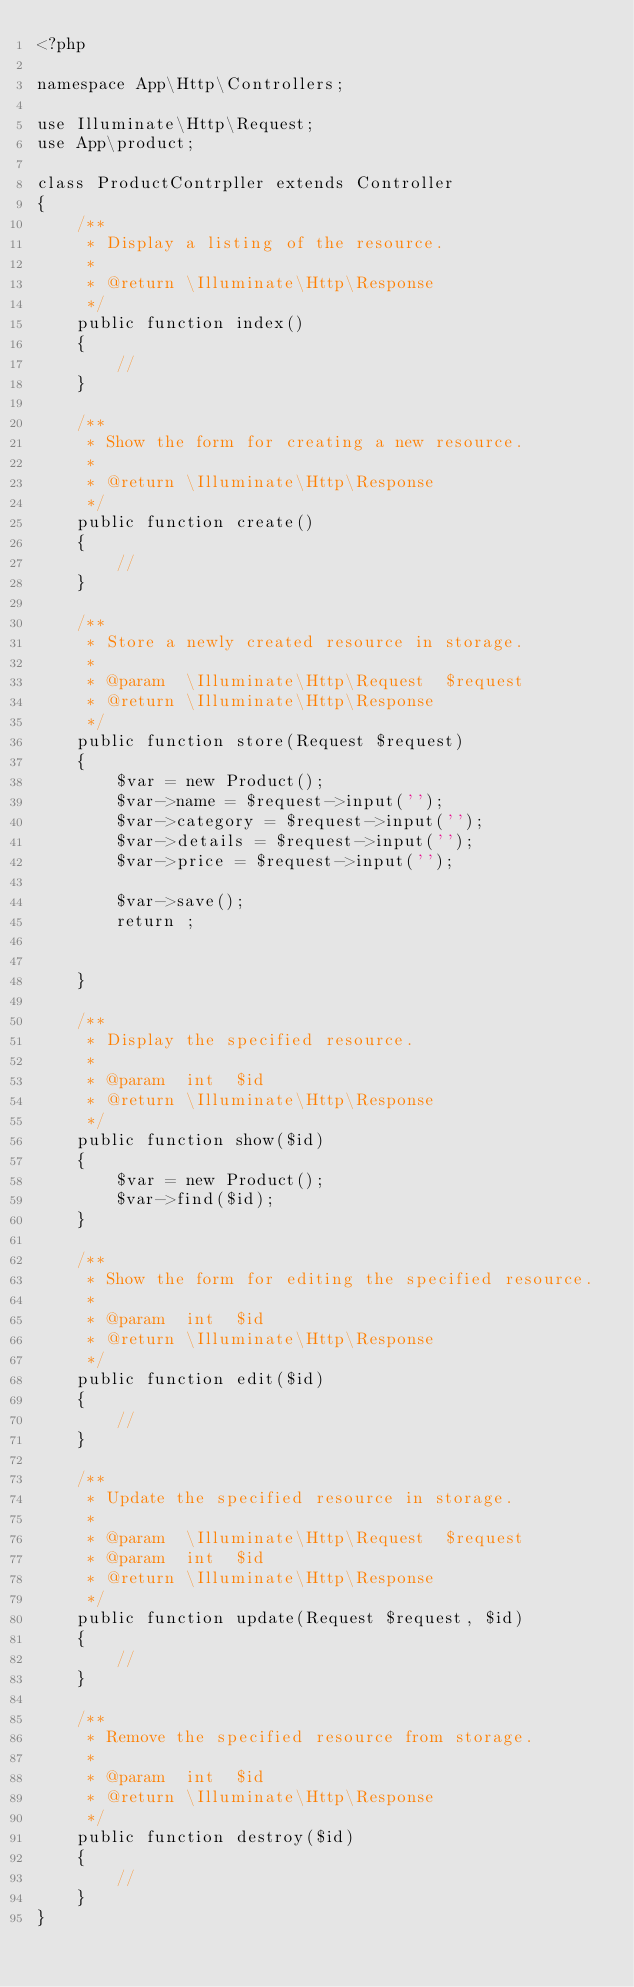Convert code to text. <code><loc_0><loc_0><loc_500><loc_500><_PHP_><?php

namespace App\Http\Controllers;

use Illuminate\Http\Request;
use App\product;

class ProductContrpller extends Controller
{
    /**
     * Display a listing of the resource.
     *
     * @return \Illuminate\Http\Response
     */
    public function index()
    {
        //
    }

    /**
     * Show the form for creating a new resource.
     *
     * @return \Illuminate\Http\Response
     */
    public function create()
    {
        //
    }

    /**
     * Store a newly created resource in storage.
     *
     * @param  \Illuminate\Http\Request  $request
     * @return \Illuminate\Http\Response
     */
    public function store(Request $request)
    {
        $var = new Product();
        $var->name = $request->input('');
        $var->category = $request->input('');
        $var->details = $request->input('');
        $var->price = $request->input('');

        $var->save();
        return ;


    }

    /**
     * Display the specified resource.
     *
     * @param  int  $id
     * @return \Illuminate\Http\Response
     */
    public function show($id)
    {
        $var = new Product();
        $var->find($id);
    }

    /**
     * Show the form for editing the specified resource.
     *
     * @param  int  $id
     * @return \Illuminate\Http\Response
     */
    public function edit($id)
    {
        //
    }

    /**
     * Update the specified resource in storage.
     *
     * @param  \Illuminate\Http\Request  $request
     * @param  int  $id
     * @return \Illuminate\Http\Response
     */
    public function update(Request $request, $id)
    {
        //
    }

    /**
     * Remove the specified resource from storage.
     *
     * @param  int  $id
     * @return \Illuminate\Http\Response
     */
    public function destroy($id)
    {
        //
    }
}
</code> 